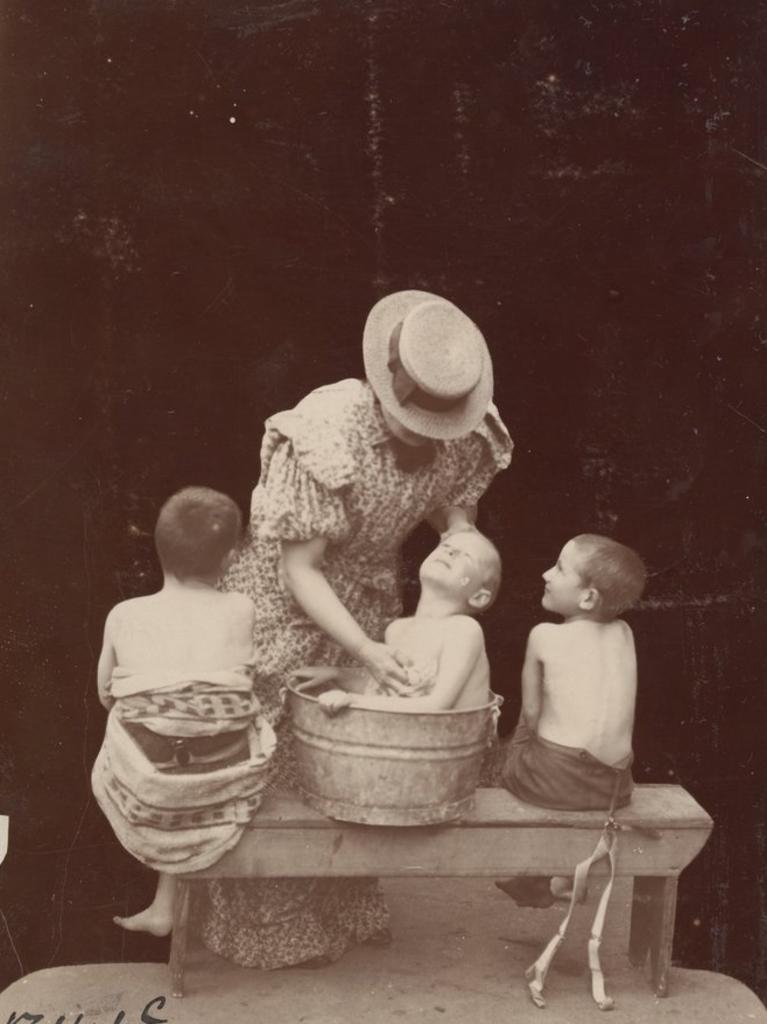Can you describe this image briefly? This is a black and white image in this image there are three boys who are sitting, and in the center there is one woman who is standing and she is wearing a hat. And in the background there is a wall. 